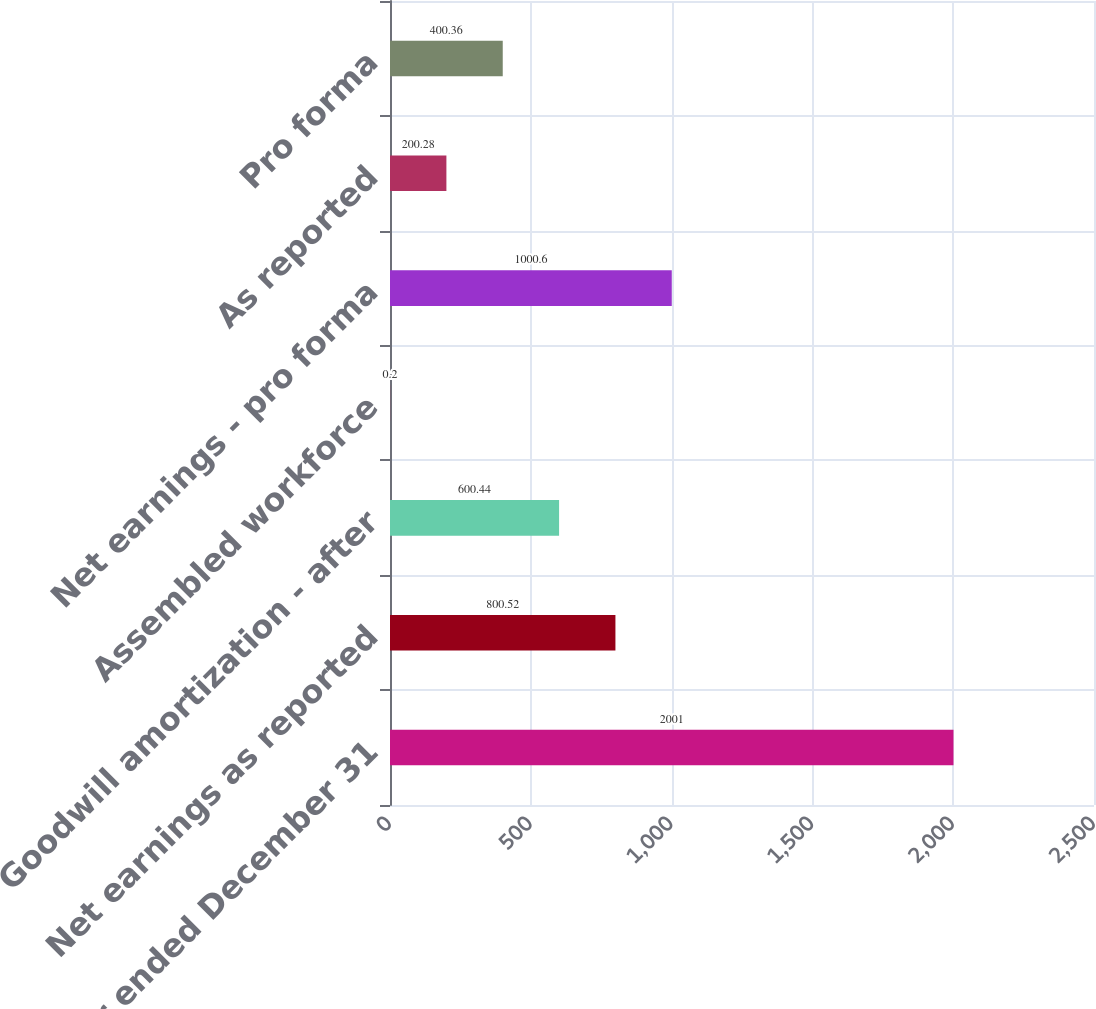Convert chart to OTSL. <chart><loc_0><loc_0><loc_500><loc_500><bar_chart><fcel>Year ended December 31<fcel>Net earnings as reported<fcel>Goodwill amortization - after<fcel>Assembled workforce<fcel>Net earnings - pro forma<fcel>As reported<fcel>Pro forma<nl><fcel>2001<fcel>800.52<fcel>600.44<fcel>0.2<fcel>1000.6<fcel>200.28<fcel>400.36<nl></chart> 